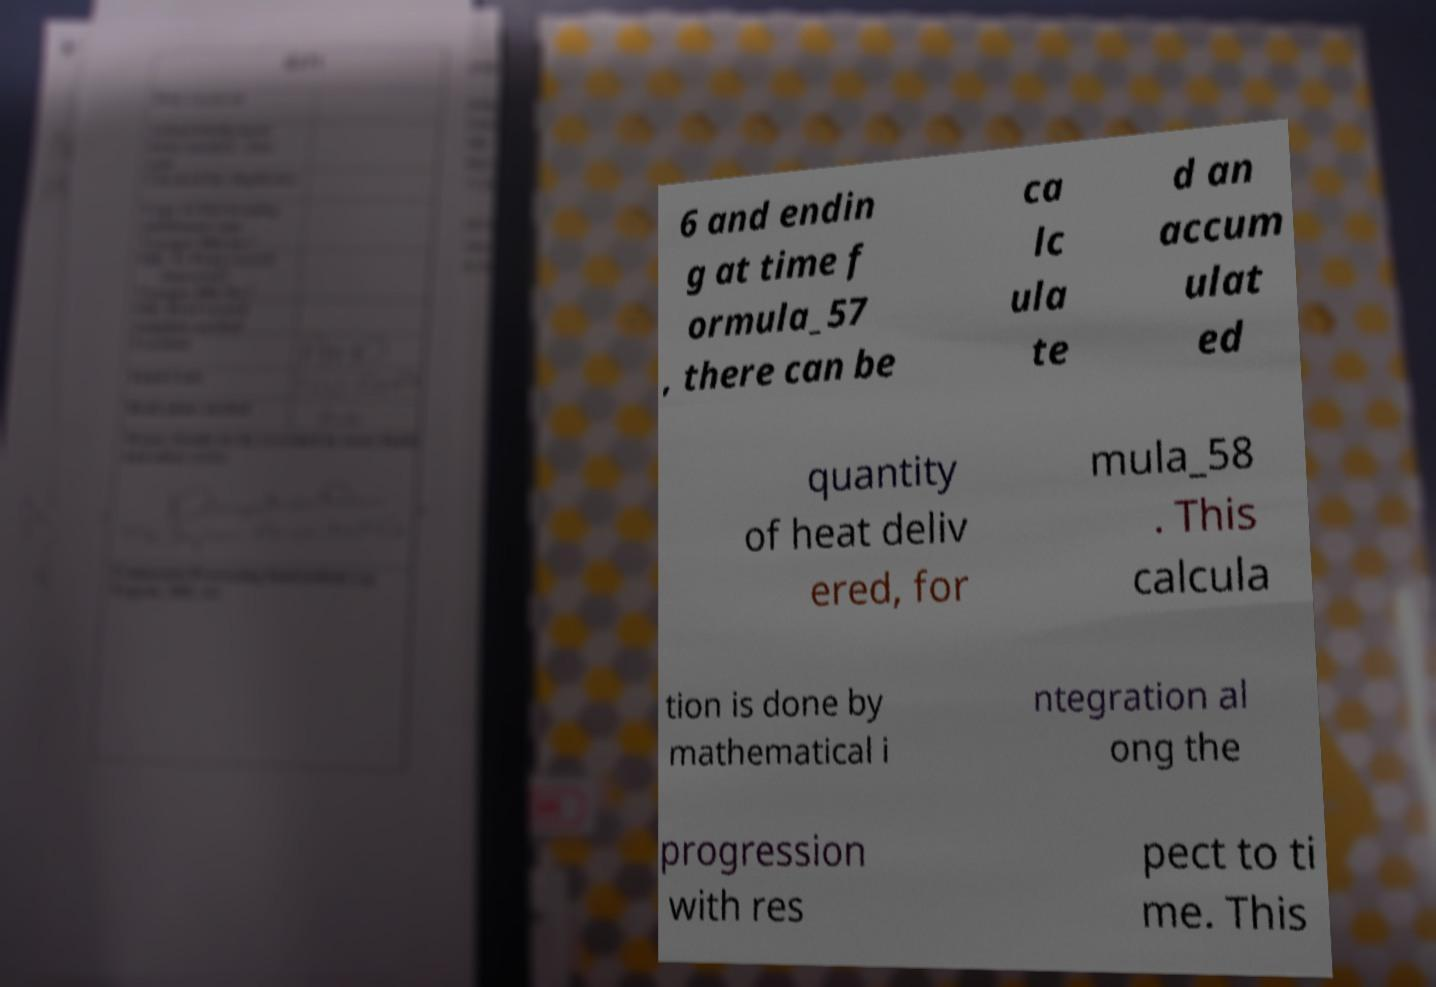Please identify and transcribe the text found in this image. 6 and endin g at time f ormula_57 , there can be ca lc ula te d an accum ulat ed quantity of heat deliv ered, for mula_58 . This calcula tion is done by mathematical i ntegration al ong the progression with res pect to ti me. This 